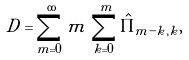Convert formula to latex. <formula><loc_0><loc_0><loc_500><loc_500>D = \sum _ { m = 0 } ^ { \infty } m \, \sum _ { k = 0 } ^ { m } \hat { \Pi } _ { m - k , k } ,</formula> 